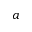Convert formula to latex. <formula><loc_0><loc_0><loc_500><loc_500>a</formula> 